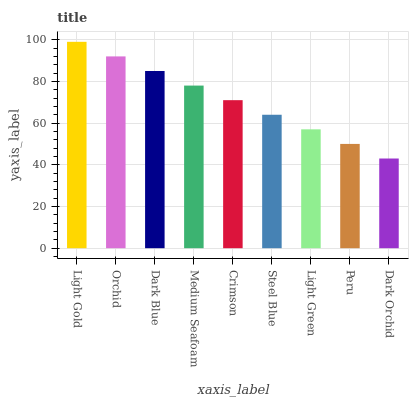Is Dark Orchid the minimum?
Answer yes or no. Yes. Is Light Gold the maximum?
Answer yes or no. Yes. Is Orchid the minimum?
Answer yes or no. No. Is Orchid the maximum?
Answer yes or no. No. Is Light Gold greater than Orchid?
Answer yes or no. Yes. Is Orchid less than Light Gold?
Answer yes or no. Yes. Is Orchid greater than Light Gold?
Answer yes or no. No. Is Light Gold less than Orchid?
Answer yes or no. No. Is Crimson the high median?
Answer yes or no. Yes. Is Crimson the low median?
Answer yes or no. Yes. Is Light Gold the high median?
Answer yes or no. No. Is Light Green the low median?
Answer yes or no. No. 